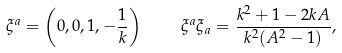Convert formula to latex. <formula><loc_0><loc_0><loc_500><loc_500>\xi ^ { a } = \left ( 0 , 0 , 1 , - \frac { 1 } { k } \right ) \quad \xi ^ { a } \xi _ { a } = \frac { k ^ { 2 } + 1 - 2 k A } { k ^ { 2 } ( A ^ { 2 } - 1 ) } ,</formula> 